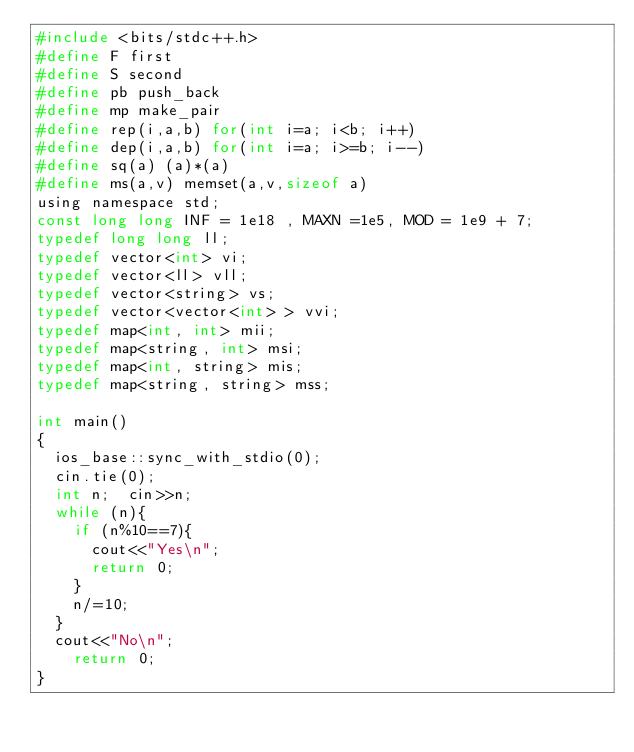Convert code to text. <code><loc_0><loc_0><loc_500><loc_500><_C_>#include <bits/stdc++.h>
#define F first
#define S second
#define pb push_back
#define mp make_pair
#define rep(i,a,b) for(int i=a; i<b; i++)
#define dep(i,a,b) for(int i=a; i>=b; i--)
#define sq(a) (a)*(a)
#define ms(a,v)	memset(a,v,sizeof a)
using namespace std;
const long long INF = 1e18 , MAXN =1e5, MOD = 1e9 + 7;
typedef long long ll;
typedef vector<int> vi;
typedef vector<ll> vll;
typedef vector<string> vs;
typedef vector<vector<int> > vvi;
typedef map<int, int> mii;
typedef map<string, int> msi;
typedef map<int, string> mis;
typedef map<string, string> mss;

int main()
{
  ios_base::sync_with_stdio(0);
  cin.tie(0);
  int n;  cin>>n;
  while (n){
    if (n%10==7){
      cout<<"Yes\n";
      return 0;
    }
    n/=10;
  }
  cout<<"No\n";
    return 0;
}
</code> 